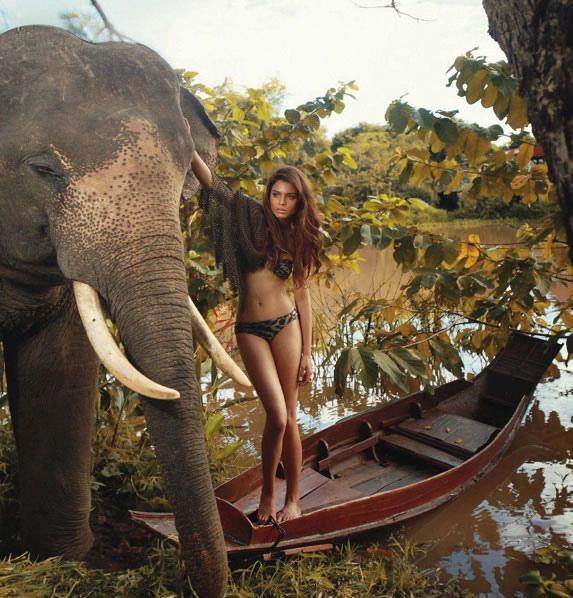Verify the accuracy of this image caption: "The elephant is on top of the boat.".
Answer yes or no. No. Verify the accuracy of this image caption: "The elephant is behind the person.".
Answer yes or no. No. Is this affirmation: "The person is touching the elephant." correct?
Answer yes or no. Yes. 